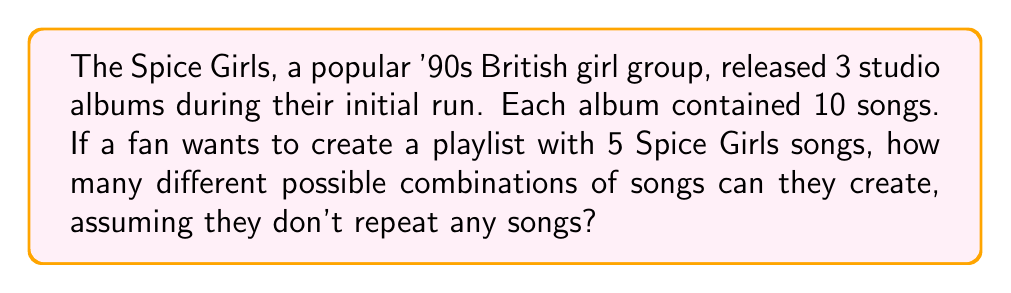Teach me how to tackle this problem. Let's approach this step-by-step:

1) First, we need to calculate the total number of Spice Girls songs:
   $3 \text{ albums} \times 10 \text{ songs per album} = 30 \text{ total songs}$

2) Now, we're selecting 5 songs out of 30, where order doesn't matter (since it's a playlist, the order of songs doesn't create a new combination) and we're not repeating songs.

3) This scenario is a perfect application of the combination formula:

   $$C(n,r) = \frac{n!}{r!(n-r)!}$$

   Where $n$ is the total number of items to choose from, and $r$ is the number of items being chosen.

4) In this case, $n = 30$ (total songs) and $r = 5$ (songs in the playlist).

5) Let's substitute these values into our formula:

   $$C(30,5) = \frac{30!}{5!(30-5)!} = \frac{30!}{5!25!}$$

6) Calculating this:
   
   $$\frac{30 \times 29 \times 28 \times 27 \times 26 \times 25!}{(5 \times 4 \times 3 \times 2 \times 1) \times 25!}$$

7) The $25!$ cancels out in the numerator and denominator:

   $$\frac{30 \times 29 \times 28 \times 27 \times 26}{5 \times 4 \times 3 \times 2 \times 1} = 142,506$$

Therefore, there are 142,506 different possible combinations of 5 Spice Girls songs for a playlist.
Answer: 142,506 possible combinations 